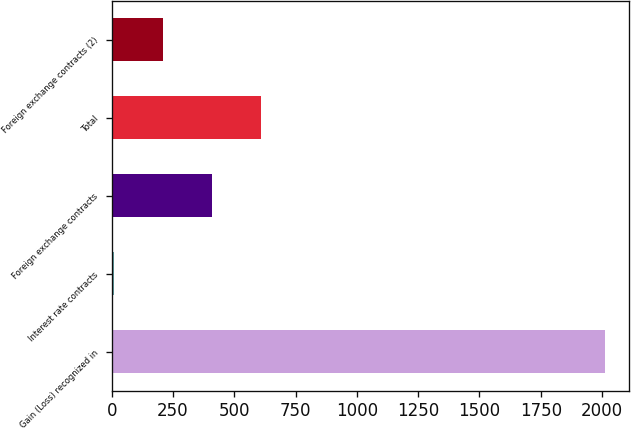<chart> <loc_0><loc_0><loc_500><loc_500><bar_chart><fcel>Gain (Loss) recognized in<fcel>Interest rate contracts<fcel>Foreign exchange contracts<fcel>Total<fcel>Foreign exchange contracts (2)<nl><fcel>2010<fcel>10<fcel>410<fcel>610<fcel>210<nl></chart> 